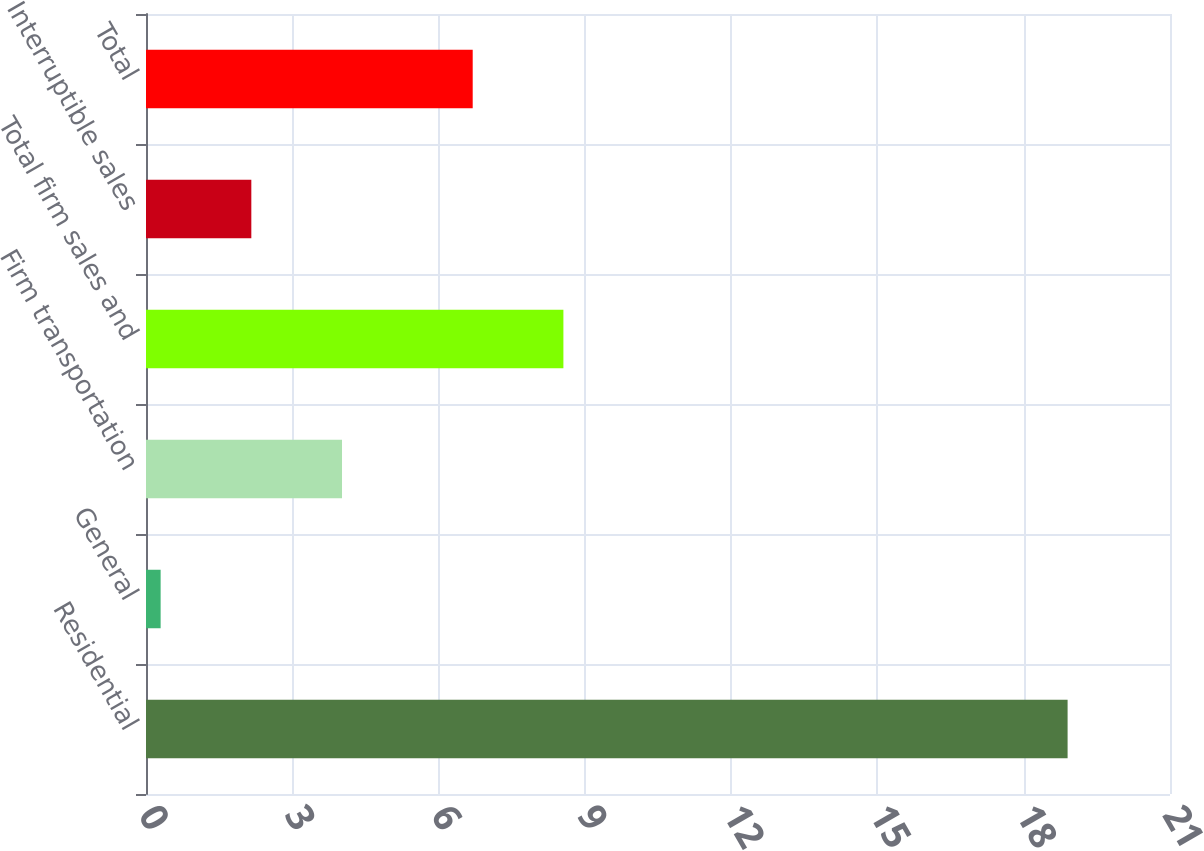Convert chart. <chart><loc_0><loc_0><loc_500><loc_500><bar_chart><fcel>Residential<fcel>General<fcel>Firm transportation<fcel>Total firm sales and<fcel>Interruptible sales<fcel>Total<nl><fcel>18.9<fcel>0.3<fcel>4.02<fcel>8.56<fcel>2.16<fcel>6.7<nl></chart> 